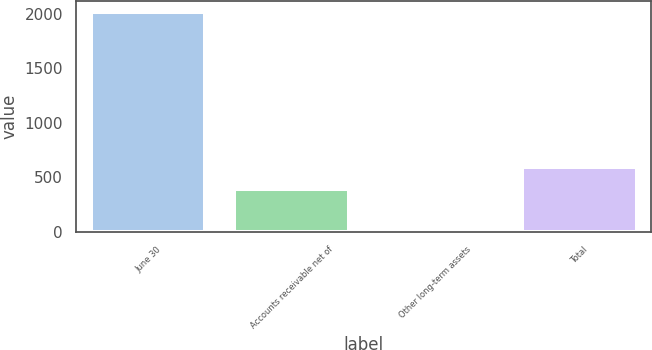Convert chart. <chart><loc_0><loc_0><loc_500><loc_500><bar_chart><fcel>June 30<fcel>Accounts receivable net of<fcel>Other long-term assets<fcel>Total<nl><fcel>2016<fcel>392<fcel>17<fcel>591.9<nl></chart> 